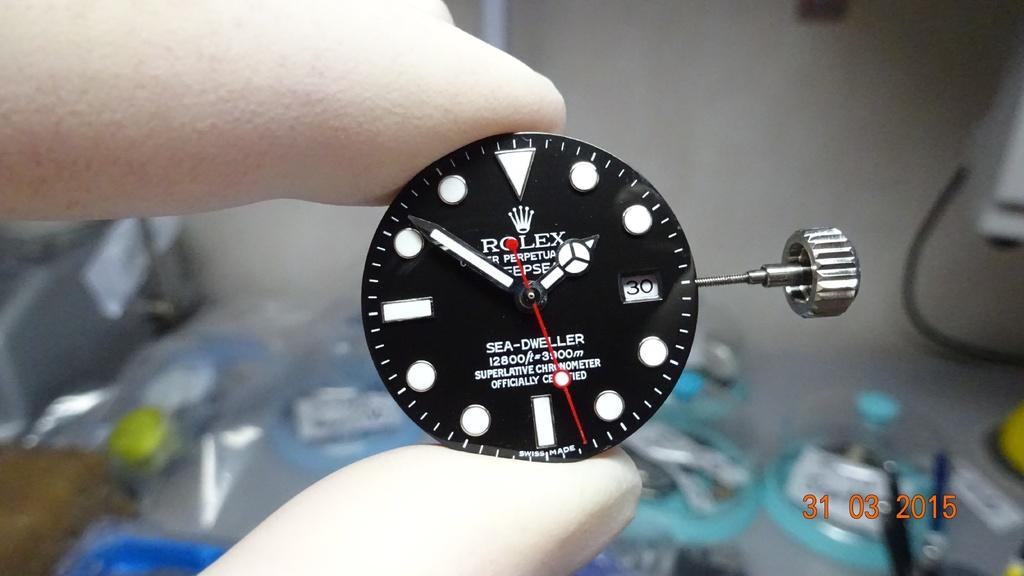<image>
Describe the image concisely. A Rolex Sea-Dweller chronometer is held up between two gloved fingers. 